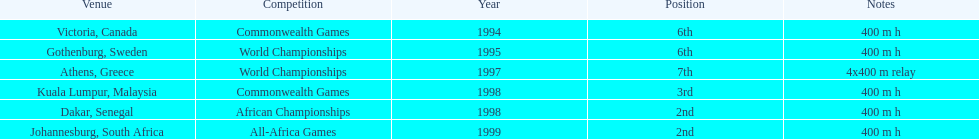What venue came before gothenburg, sweden? Victoria, Canada. 